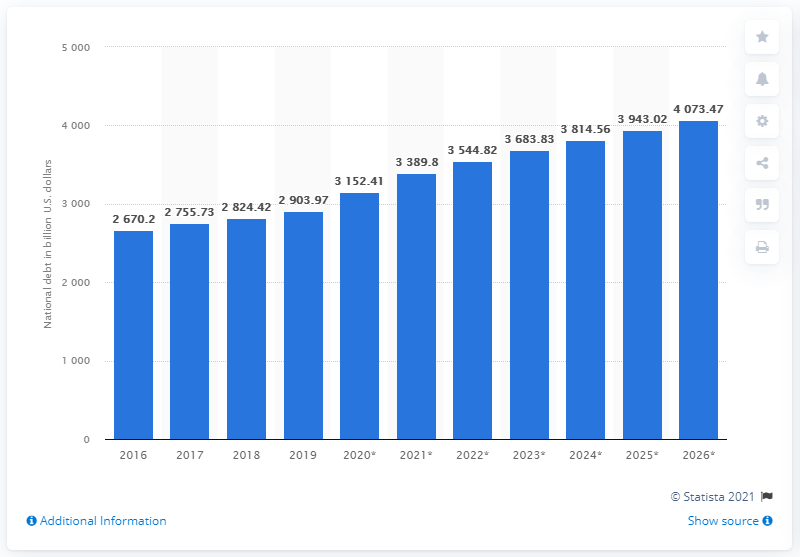Specify some key components in this picture. The national debt of France in 2019 was 2903.97... 